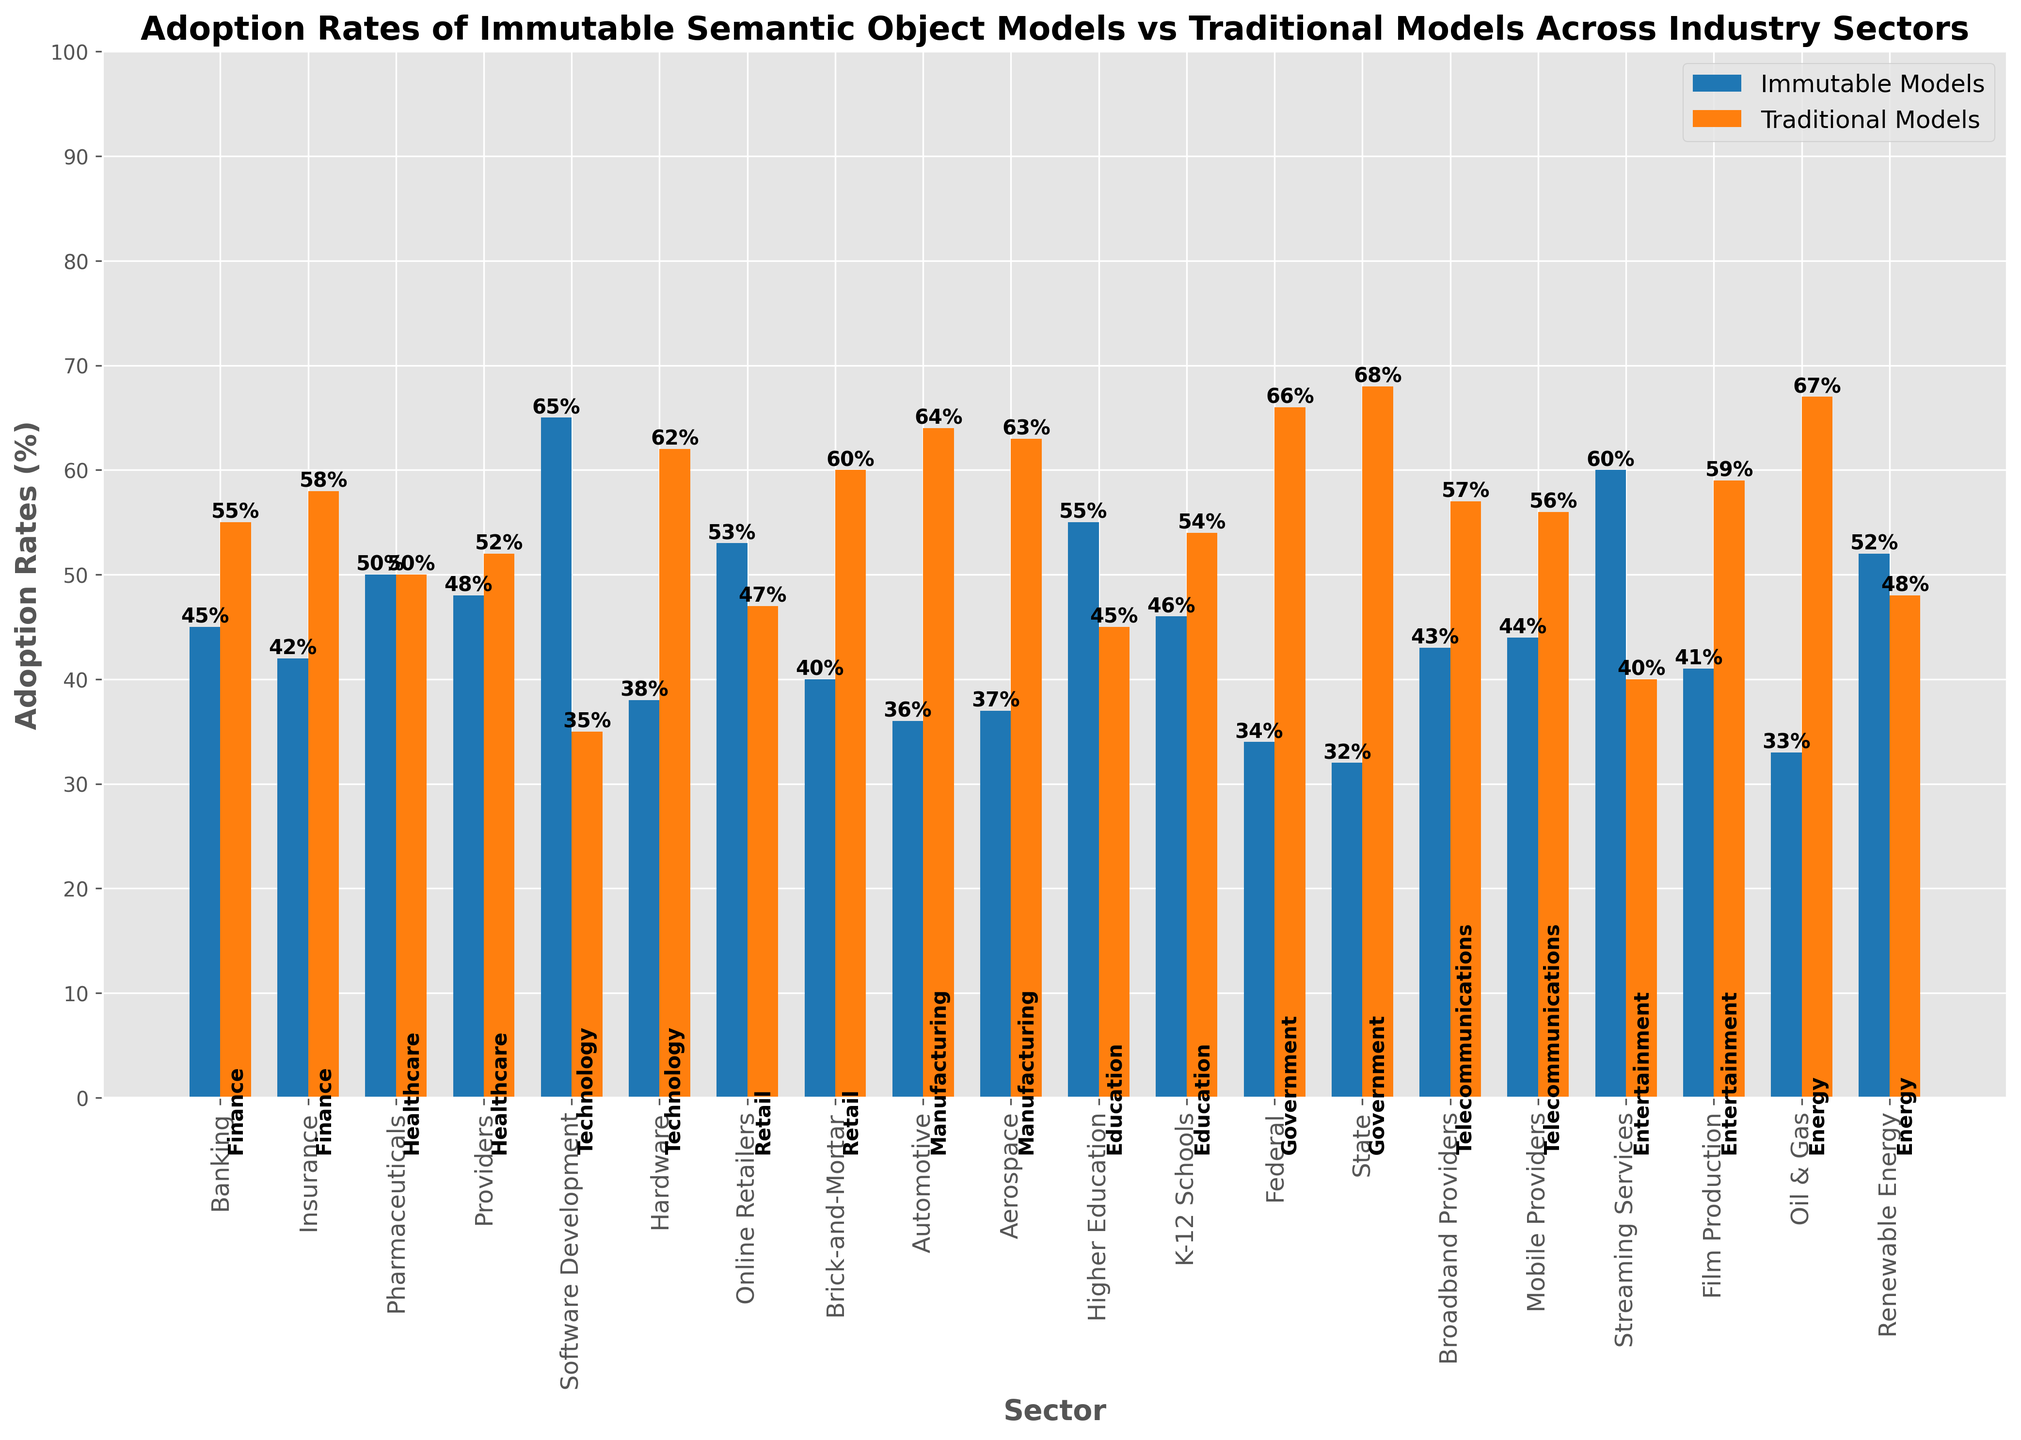what is the most adopted model in the Software Development sector? The Software Development sector falls under the Technology industry. The figure shows two bars for this sector. The height of the bar representing Immutable Models is higher compared to the Traditional Models. This indicates that Immutable Models have the higher adoption rate in the Software Development sector.
Answer: Immutable Models what’s the ratio of Traditional to Immutable Models adoption in the Renewable Energy sector? In the Energy industry, specifically in the Renewable Energy sector, the figure shows that the adoption rates are 52% for Immutable Models and 48% for Traditional Models. The ratio of Traditional to Immutable Models is 48/52.
Answer: 48/52 which sector in the Healthcare industry has a higher adoption rate for Immutable Models? Healthcare includes Pharmaceuticals and Providers sectors. By comparing the bars, Immutable Models have higher adoption rates in the Pharmaceuticals sector (50%) compared to Providers (48%).
Answer: Pharmaceuticals what is the difference in adoption rates between Immutable and Traditional Models in K-12 Schools? The figure for the Education industry shows that in the K-12 Schools sector, the adoption rate for Immutable Models is 46% and for Traditional Models is 54%. The difference is 54 - 46.
Answer: 8% which industry has the highest adoption rate of Immutable Models and what is the rate? By comparing the heights of all the bars labeled as 'Immutable Models', the Software Development sector under the Technology industry has the highest adoption rate at 65%.
Answer: Technology, 65% which sector has the lowest adoption rate of Immutable Models? By visually examining the shortest bar under Immutable Models across sectors, the Government sector (State) has the lowest adoption rate at 32%.
Answer: State Government what’s the extra adoption percentage of Traditional Models over Immutable Models in Federal Government? In the Federal Government sector under Government, Traditional Models have an adoption rate of 66%, while Immutable Models have 34%. The additional percentage is the difference 66 - 34.
Answer: 32% what is the cumulative adoption rate of Immutable Models across all Education sectors? For Education, Higher Education has 55% and K-12 Schools has 46% adoption rates. Adding these together: 55 + 46.
Answer: 101% which sectors within the Technology industry have a higher adoption of Traditional Models? In Technology, the Hardware sector has a higher adoption rate of Traditional Models (62%) than Immutable Models (38%), unlike the Software Development sector where Immutable Models are more adopted.
Answer: Hardware how much higher is the adoption rate of Immutable Models in Streaming Services compared to Film Production? In the Entertainment industry, Streaming Services have a 60% adoption rate for Immutable Models, whereas Film Production has 41%. The difference is 60 - 41.
Answer: 19% 